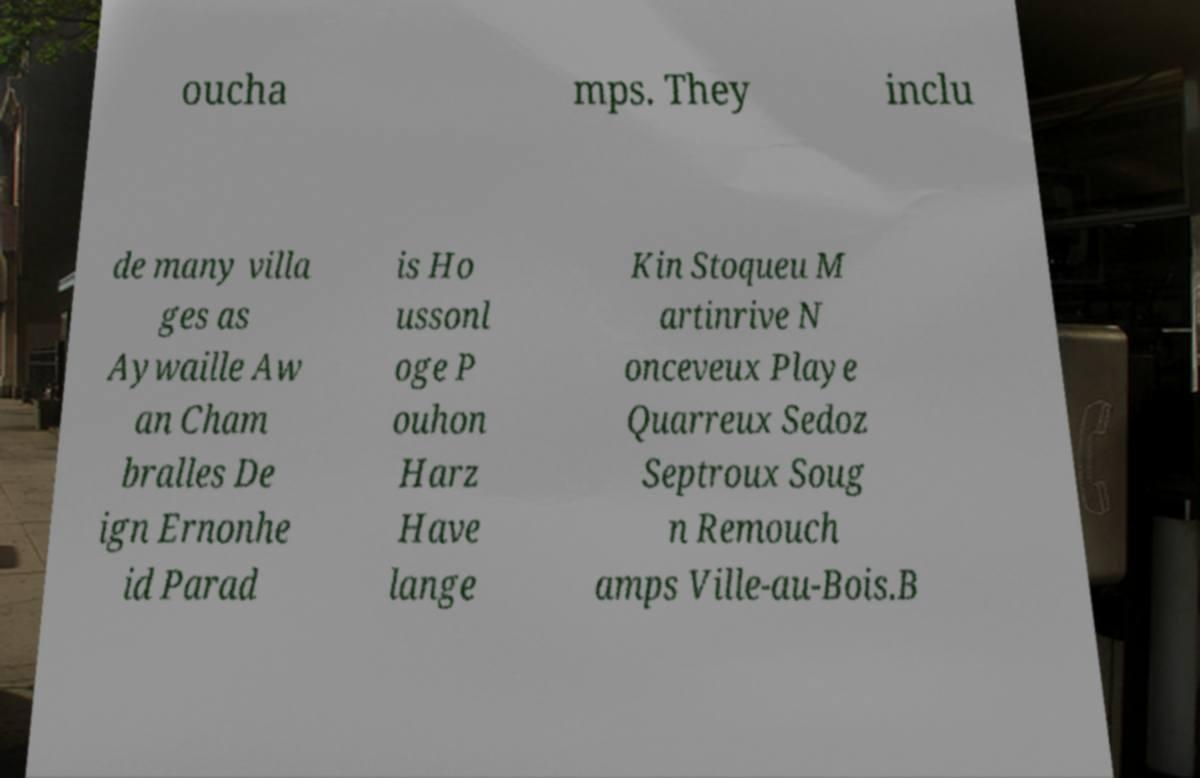I need the written content from this picture converted into text. Can you do that? oucha mps. They inclu de many villa ges as Aywaille Aw an Cham bralles De ign Ernonhe id Parad is Ho ussonl oge P ouhon Harz Have lange Kin Stoqueu M artinrive N onceveux Playe Quarreux Sedoz Septroux Soug n Remouch amps Ville-au-Bois.B 